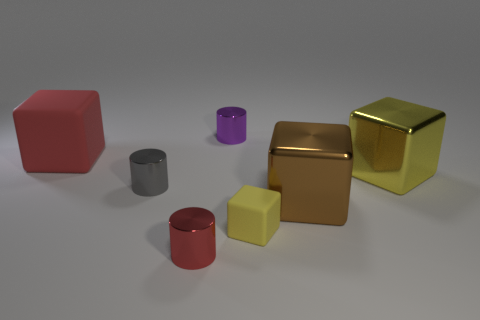Subtract all gray blocks. Subtract all cyan balls. How many blocks are left? 4 Add 1 gray things. How many objects exist? 8 Subtract all blocks. How many objects are left? 3 Add 3 tiny blue cylinders. How many tiny blue cylinders exist? 3 Subtract 0 yellow spheres. How many objects are left? 7 Subtract all big red shiny blocks. Subtract all tiny rubber cubes. How many objects are left? 6 Add 3 big brown things. How many big brown things are left? 4 